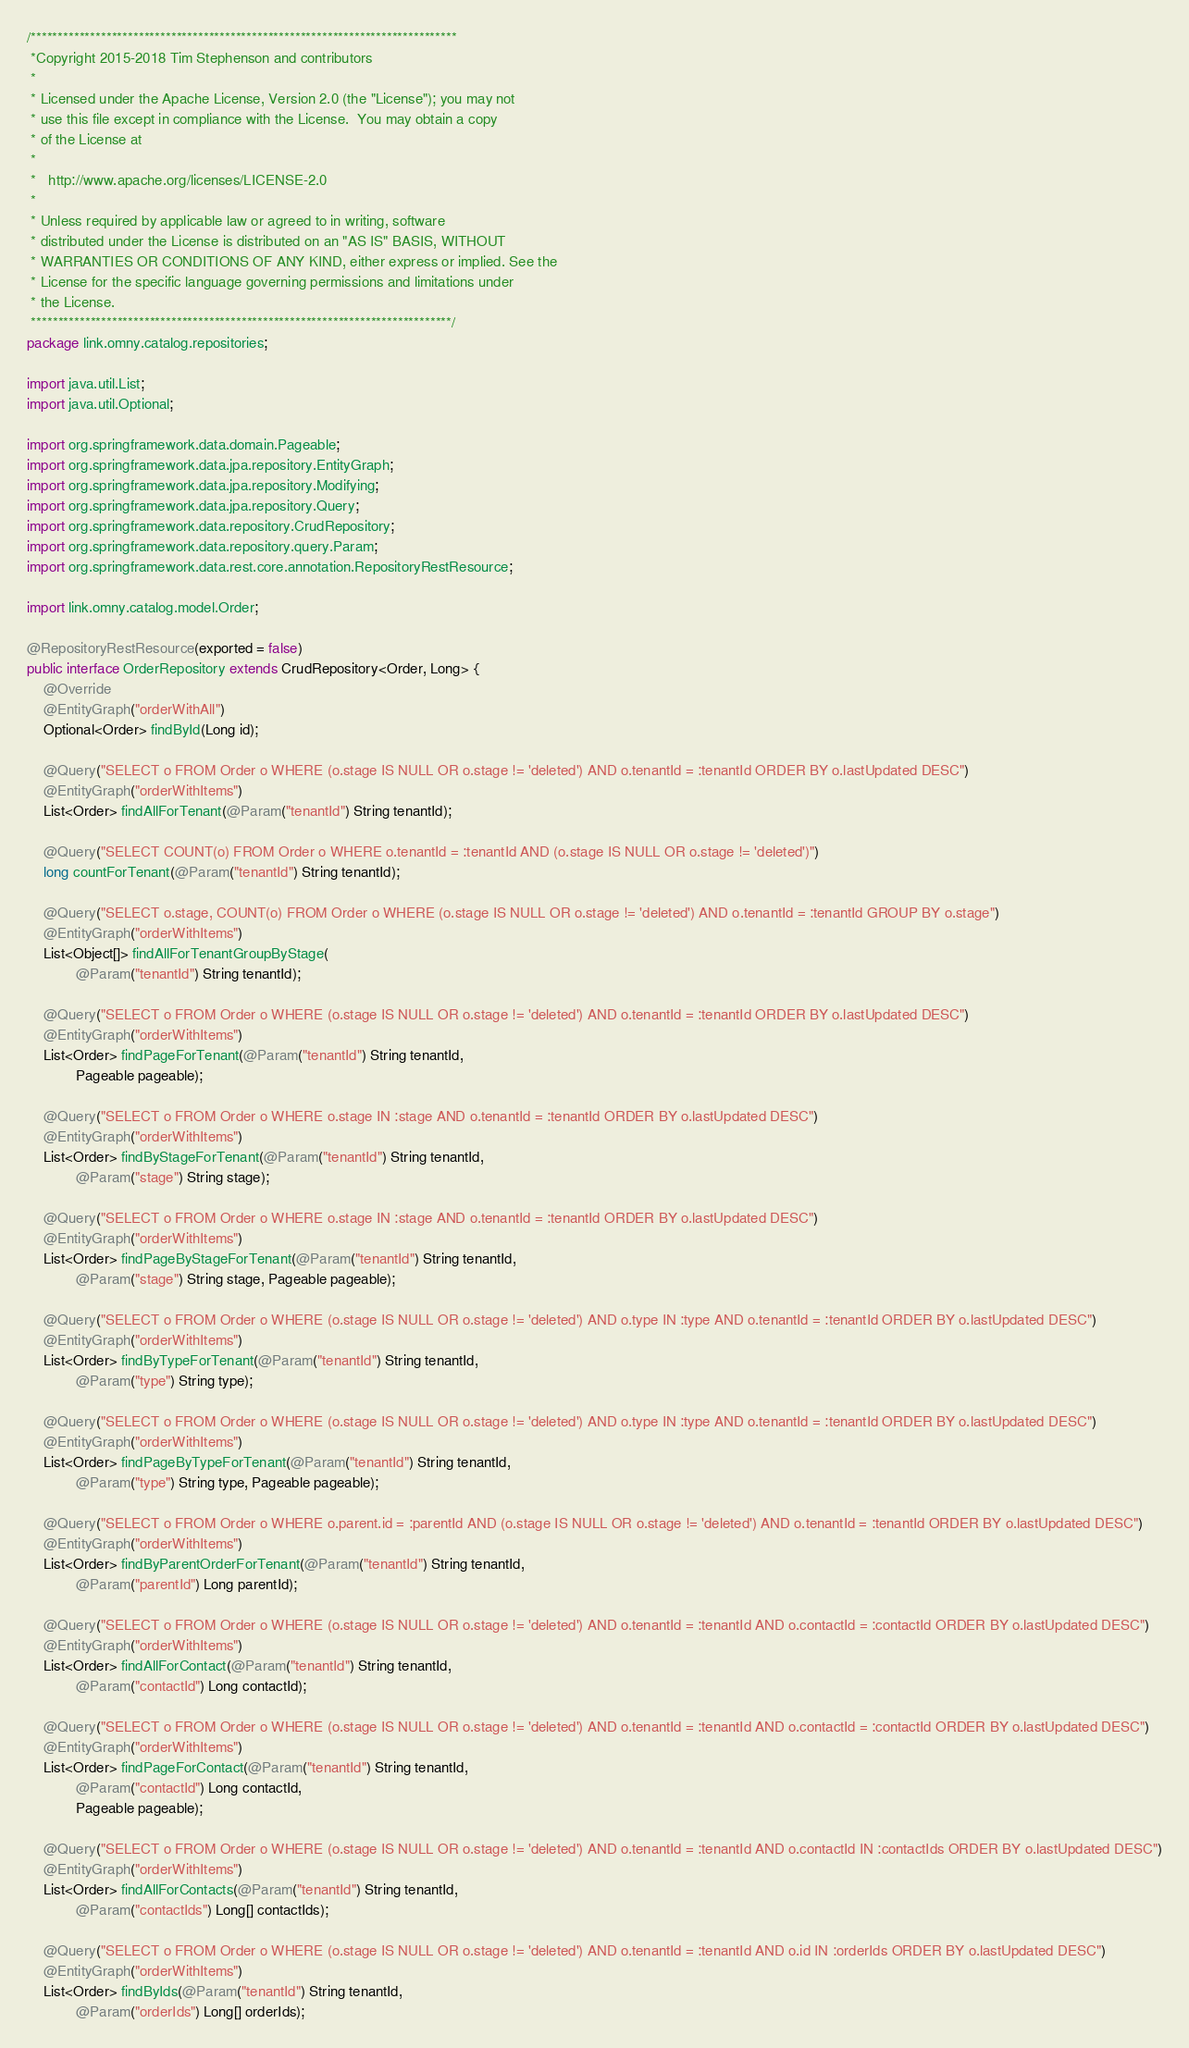<code> <loc_0><loc_0><loc_500><loc_500><_Java_>/*******************************************************************************
 *Copyright 2015-2018 Tim Stephenson and contributors
 *
 * Licensed under the Apache License, Version 2.0 (the "License"); you may not
 * use this file except in compliance with the License.  You may obtain a copy
 * of the License at
 *
 *   http://www.apache.org/licenses/LICENSE-2.0
 *
 * Unless required by applicable law or agreed to in writing, software
 * distributed under the License is distributed on an "AS IS" BASIS, WITHOUT
 * WARRANTIES OR CONDITIONS OF ANY KIND, either express or implied. See the
 * License for the specific language governing permissions and limitations under
 * the License.
 ******************************************************************************/
package link.omny.catalog.repositories;

import java.util.List;
import java.util.Optional;

import org.springframework.data.domain.Pageable;
import org.springframework.data.jpa.repository.EntityGraph;
import org.springframework.data.jpa.repository.Modifying;
import org.springframework.data.jpa.repository.Query;
import org.springframework.data.repository.CrudRepository;
import org.springframework.data.repository.query.Param;
import org.springframework.data.rest.core.annotation.RepositoryRestResource;

import link.omny.catalog.model.Order;

@RepositoryRestResource(exported = false)
public interface OrderRepository extends CrudRepository<Order, Long> {
    @Override
    @EntityGraph("orderWithAll")
    Optional<Order> findById(Long id);

    @Query("SELECT o FROM Order o WHERE (o.stage IS NULL OR o.stage != 'deleted') AND o.tenantId = :tenantId ORDER BY o.lastUpdated DESC")
    @EntityGraph("orderWithItems")
    List<Order> findAllForTenant(@Param("tenantId") String tenantId);

    @Query("SELECT COUNT(o) FROM Order o WHERE o.tenantId = :tenantId AND (o.stage IS NULL OR o.stage != 'deleted')")
    long countForTenant(@Param("tenantId") String tenantId);

    @Query("SELECT o.stage, COUNT(o) FROM Order o WHERE (o.stage IS NULL OR o.stage != 'deleted') AND o.tenantId = :tenantId GROUP BY o.stage")
    @EntityGraph("orderWithItems")
    List<Object[]> findAllForTenantGroupByStage(
            @Param("tenantId") String tenantId);

    @Query("SELECT o FROM Order o WHERE (o.stage IS NULL OR o.stage != 'deleted') AND o.tenantId = :tenantId ORDER BY o.lastUpdated DESC")
    @EntityGraph("orderWithItems")
    List<Order> findPageForTenant(@Param("tenantId") String tenantId,
            Pageable pageable);

    @Query("SELECT o FROM Order o WHERE o.stage IN :stage AND o.tenantId = :tenantId ORDER BY o.lastUpdated DESC")
    @EntityGraph("orderWithItems")
    List<Order> findByStageForTenant(@Param("tenantId") String tenantId,
            @Param("stage") String stage);

    @Query("SELECT o FROM Order o WHERE o.stage IN :stage AND o.tenantId = :tenantId ORDER BY o.lastUpdated DESC")
    @EntityGraph("orderWithItems")
    List<Order> findPageByStageForTenant(@Param("tenantId") String tenantId,
            @Param("stage") String stage, Pageable pageable);

    @Query("SELECT o FROM Order o WHERE (o.stage IS NULL OR o.stage != 'deleted') AND o.type IN :type AND o.tenantId = :tenantId ORDER BY o.lastUpdated DESC")
    @EntityGraph("orderWithItems")
    List<Order> findByTypeForTenant(@Param("tenantId") String tenantId,
            @Param("type") String type);

    @Query("SELECT o FROM Order o WHERE (o.stage IS NULL OR o.stage != 'deleted') AND o.type IN :type AND o.tenantId = :tenantId ORDER BY o.lastUpdated DESC")
    @EntityGraph("orderWithItems")
    List<Order> findPageByTypeForTenant(@Param("tenantId") String tenantId,
            @Param("type") String type, Pageable pageable);

    @Query("SELECT o FROM Order o WHERE o.parent.id = :parentId AND (o.stage IS NULL OR o.stage != 'deleted') AND o.tenantId = :tenantId ORDER BY o.lastUpdated DESC")
    @EntityGraph("orderWithItems")
    List<Order> findByParentOrderForTenant(@Param("tenantId") String tenantId,
            @Param("parentId") Long parentId);

    @Query("SELECT o FROM Order o WHERE (o.stage IS NULL OR o.stage != 'deleted') AND o.tenantId = :tenantId AND o.contactId = :contactId ORDER BY o.lastUpdated DESC")
    @EntityGraph("orderWithItems")
    List<Order> findAllForContact(@Param("tenantId") String tenantId,
            @Param("contactId") Long contactId);

    @Query("SELECT o FROM Order o WHERE (o.stage IS NULL OR o.stage != 'deleted') AND o.tenantId = :tenantId AND o.contactId = :contactId ORDER BY o.lastUpdated DESC")
    @EntityGraph("orderWithItems")
    List<Order> findPageForContact(@Param("tenantId") String tenantId,
            @Param("contactId") Long contactId,
            Pageable pageable);

    @Query("SELECT o FROM Order o WHERE (o.stage IS NULL OR o.stage != 'deleted') AND o.tenantId = :tenantId AND o.contactId IN :contactIds ORDER BY o.lastUpdated DESC")
    @EntityGraph("orderWithItems")
    List<Order> findAllForContacts(@Param("tenantId") String tenantId,
            @Param("contactIds") Long[] contactIds);

    @Query("SELECT o FROM Order o WHERE (o.stage IS NULL OR o.stage != 'deleted') AND o.tenantId = :tenantId AND o.id IN :orderIds ORDER BY o.lastUpdated DESC")
    @EntityGraph("orderWithItems")
    List<Order> findByIds(@Param("tenantId") String tenantId,
            @Param("orderIds") Long[] orderIds);
</code> 